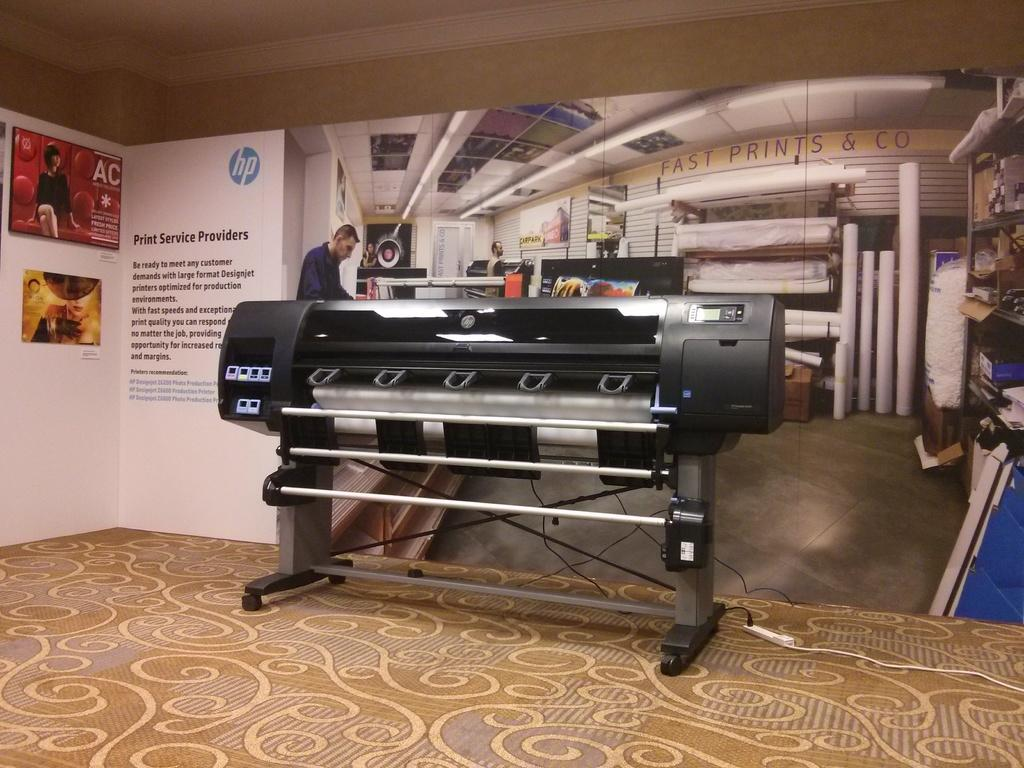What type of equipment is present in the room? There is a printing machine in the room. What can be seen on the wall in the background? There is a poster on the wall in the background. What information is included on the poster? The poster contains text and images. What type of nest can be seen in the image? There is no nest present in the image. 